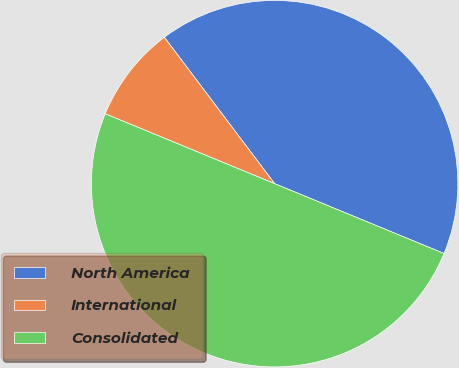Convert chart to OTSL. <chart><loc_0><loc_0><loc_500><loc_500><pie_chart><fcel>North America<fcel>International<fcel>Consolidated<nl><fcel>41.5%<fcel>8.5%<fcel>50.0%<nl></chart> 